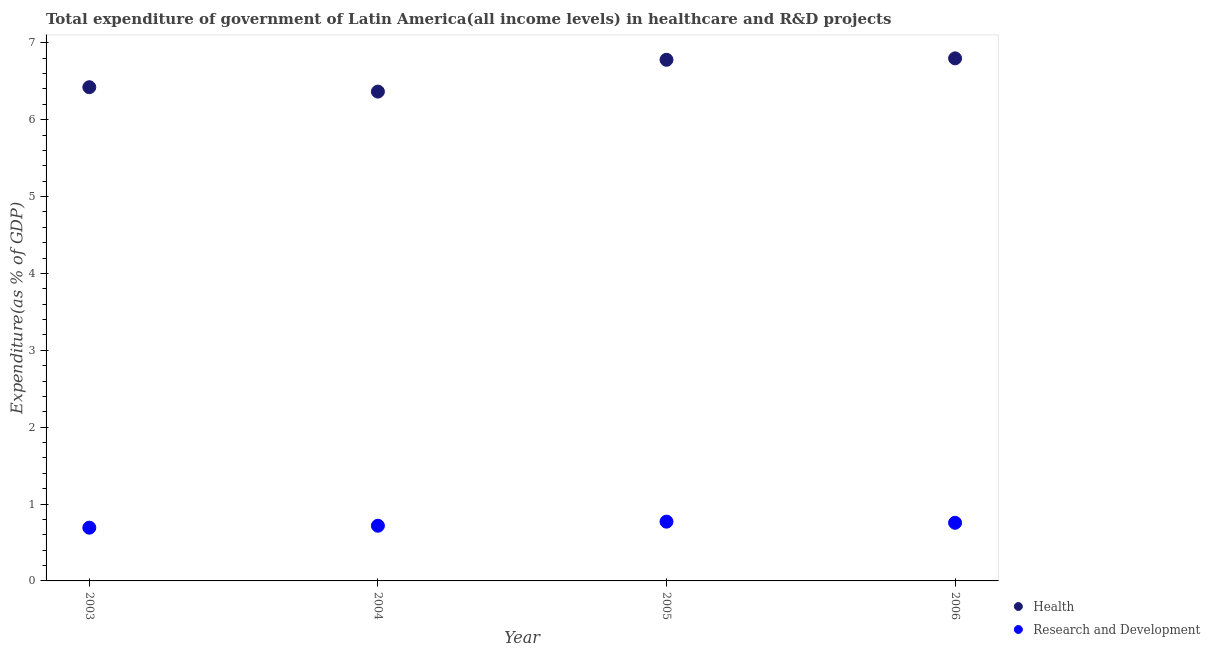What is the expenditure in healthcare in 2005?
Your answer should be compact. 6.78. Across all years, what is the maximum expenditure in r&d?
Offer a very short reply. 0.77. Across all years, what is the minimum expenditure in healthcare?
Offer a terse response. 6.37. In which year was the expenditure in healthcare maximum?
Ensure brevity in your answer.  2006. What is the total expenditure in healthcare in the graph?
Your answer should be compact. 26.37. What is the difference between the expenditure in healthcare in 2003 and that in 2004?
Provide a succinct answer. 0.06. What is the difference between the expenditure in r&d in 2006 and the expenditure in healthcare in 2004?
Offer a terse response. -5.61. What is the average expenditure in healthcare per year?
Provide a short and direct response. 6.59. In the year 2006, what is the difference between the expenditure in healthcare and expenditure in r&d?
Your response must be concise. 6.04. In how many years, is the expenditure in r&d greater than 2.8 %?
Make the answer very short. 0. What is the ratio of the expenditure in r&d in 2003 to that in 2005?
Offer a very short reply. 0.9. Is the expenditure in r&d in 2005 less than that in 2006?
Provide a succinct answer. No. Is the difference between the expenditure in r&d in 2004 and 2005 greater than the difference between the expenditure in healthcare in 2004 and 2005?
Your answer should be very brief. Yes. What is the difference between the highest and the second highest expenditure in healthcare?
Ensure brevity in your answer.  0.02. What is the difference between the highest and the lowest expenditure in healthcare?
Offer a very short reply. 0.43. In how many years, is the expenditure in r&d greater than the average expenditure in r&d taken over all years?
Provide a short and direct response. 2. Is the sum of the expenditure in healthcare in 2003 and 2004 greater than the maximum expenditure in r&d across all years?
Your answer should be very brief. Yes. Is the expenditure in r&d strictly greater than the expenditure in healthcare over the years?
Ensure brevity in your answer.  No. Does the graph contain any zero values?
Your response must be concise. No. What is the title of the graph?
Your answer should be compact. Total expenditure of government of Latin America(all income levels) in healthcare and R&D projects. What is the label or title of the X-axis?
Provide a short and direct response. Year. What is the label or title of the Y-axis?
Give a very brief answer. Expenditure(as % of GDP). What is the Expenditure(as % of GDP) of Health in 2003?
Provide a short and direct response. 6.42. What is the Expenditure(as % of GDP) of Research and Development in 2003?
Your answer should be very brief. 0.69. What is the Expenditure(as % of GDP) in Health in 2004?
Your response must be concise. 6.37. What is the Expenditure(as % of GDP) in Research and Development in 2004?
Keep it short and to the point. 0.72. What is the Expenditure(as % of GDP) of Health in 2005?
Provide a short and direct response. 6.78. What is the Expenditure(as % of GDP) of Research and Development in 2005?
Offer a very short reply. 0.77. What is the Expenditure(as % of GDP) in Health in 2006?
Keep it short and to the point. 6.8. What is the Expenditure(as % of GDP) in Research and Development in 2006?
Ensure brevity in your answer.  0.76. Across all years, what is the maximum Expenditure(as % of GDP) of Health?
Your answer should be very brief. 6.8. Across all years, what is the maximum Expenditure(as % of GDP) in Research and Development?
Offer a terse response. 0.77. Across all years, what is the minimum Expenditure(as % of GDP) of Health?
Offer a terse response. 6.37. Across all years, what is the minimum Expenditure(as % of GDP) in Research and Development?
Ensure brevity in your answer.  0.69. What is the total Expenditure(as % of GDP) of Health in the graph?
Your answer should be very brief. 26.37. What is the total Expenditure(as % of GDP) of Research and Development in the graph?
Give a very brief answer. 2.94. What is the difference between the Expenditure(as % of GDP) of Health in 2003 and that in 2004?
Offer a very short reply. 0.06. What is the difference between the Expenditure(as % of GDP) of Research and Development in 2003 and that in 2004?
Your answer should be very brief. -0.03. What is the difference between the Expenditure(as % of GDP) in Health in 2003 and that in 2005?
Provide a succinct answer. -0.36. What is the difference between the Expenditure(as % of GDP) of Research and Development in 2003 and that in 2005?
Offer a terse response. -0.08. What is the difference between the Expenditure(as % of GDP) of Health in 2003 and that in 2006?
Ensure brevity in your answer.  -0.38. What is the difference between the Expenditure(as % of GDP) in Research and Development in 2003 and that in 2006?
Your response must be concise. -0.06. What is the difference between the Expenditure(as % of GDP) in Health in 2004 and that in 2005?
Offer a terse response. -0.41. What is the difference between the Expenditure(as % of GDP) in Research and Development in 2004 and that in 2005?
Provide a short and direct response. -0.05. What is the difference between the Expenditure(as % of GDP) in Health in 2004 and that in 2006?
Offer a very short reply. -0.43. What is the difference between the Expenditure(as % of GDP) in Research and Development in 2004 and that in 2006?
Provide a succinct answer. -0.04. What is the difference between the Expenditure(as % of GDP) in Health in 2005 and that in 2006?
Make the answer very short. -0.02. What is the difference between the Expenditure(as % of GDP) in Research and Development in 2005 and that in 2006?
Your answer should be compact. 0.01. What is the difference between the Expenditure(as % of GDP) of Health in 2003 and the Expenditure(as % of GDP) of Research and Development in 2004?
Your answer should be compact. 5.71. What is the difference between the Expenditure(as % of GDP) of Health in 2003 and the Expenditure(as % of GDP) of Research and Development in 2005?
Offer a terse response. 5.65. What is the difference between the Expenditure(as % of GDP) of Health in 2003 and the Expenditure(as % of GDP) of Research and Development in 2006?
Your answer should be very brief. 5.67. What is the difference between the Expenditure(as % of GDP) in Health in 2004 and the Expenditure(as % of GDP) in Research and Development in 2005?
Provide a succinct answer. 5.6. What is the difference between the Expenditure(as % of GDP) in Health in 2004 and the Expenditure(as % of GDP) in Research and Development in 2006?
Your response must be concise. 5.61. What is the difference between the Expenditure(as % of GDP) in Health in 2005 and the Expenditure(as % of GDP) in Research and Development in 2006?
Your answer should be compact. 6.02. What is the average Expenditure(as % of GDP) of Health per year?
Offer a terse response. 6.59. What is the average Expenditure(as % of GDP) in Research and Development per year?
Ensure brevity in your answer.  0.73. In the year 2003, what is the difference between the Expenditure(as % of GDP) of Health and Expenditure(as % of GDP) of Research and Development?
Offer a terse response. 5.73. In the year 2004, what is the difference between the Expenditure(as % of GDP) of Health and Expenditure(as % of GDP) of Research and Development?
Provide a succinct answer. 5.65. In the year 2005, what is the difference between the Expenditure(as % of GDP) in Health and Expenditure(as % of GDP) in Research and Development?
Provide a short and direct response. 6.01. In the year 2006, what is the difference between the Expenditure(as % of GDP) in Health and Expenditure(as % of GDP) in Research and Development?
Offer a very short reply. 6.04. What is the ratio of the Expenditure(as % of GDP) of Health in 2003 to that in 2004?
Give a very brief answer. 1.01. What is the ratio of the Expenditure(as % of GDP) of Research and Development in 2003 to that in 2004?
Offer a terse response. 0.96. What is the ratio of the Expenditure(as % of GDP) of Research and Development in 2003 to that in 2005?
Offer a terse response. 0.9. What is the ratio of the Expenditure(as % of GDP) in Health in 2003 to that in 2006?
Ensure brevity in your answer.  0.94. What is the ratio of the Expenditure(as % of GDP) of Research and Development in 2003 to that in 2006?
Provide a short and direct response. 0.92. What is the ratio of the Expenditure(as % of GDP) in Health in 2004 to that in 2005?
Offer a terse response. 0.94. What is the ratio of the Expenditure(as % of GDP) of Research and Development in 2004 to that in 2005?
Keep it short and to the point. 0.93. What is the ratio of the Expenditure(as % of GDP) of Health in 2004 to that in 2006?
Ensure brevity in your answer.  0.94. What is the ratio of the Expenditure(as % of GDP) of Research and Development in 2004 to that in 2006?
Your answer should be very brief. 0.95. What is the ratio of the Expenditure(as % of GDP) of Research and Development in 2005 to that in 2006?
Provide a succinct answer. 1.02. What is the difference between the highest and the second highest Expenditure(as % of GDP) of Health?
Give a very brief answer. 0.02. What is the difference between the highest and the second highest Expenditure(as % of GDP) in Research and Development?
Keep it short and to the point. 0.01. What is the difference between the highest and the lowest Expenditure(as % of GDP) of Health?
Make the answer very short. 0.43. What is the difference between the highest and the lowest Expenditure(as % of GDP) of Research and Development?
Provide a succinct answer. 0.08. 